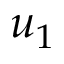<formula> <loc_0><loc_0><loc_500><loc_500>u _ { 1 }</formula> 